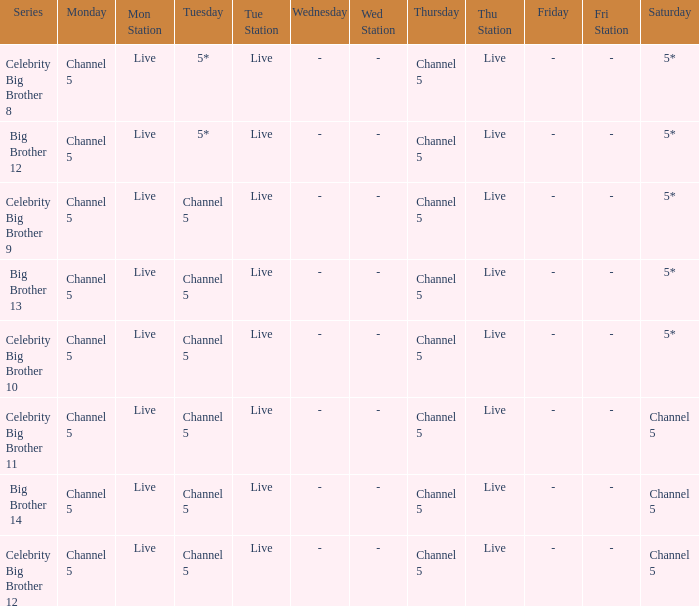Which Tuesday does big brother 12 air? 5*. 